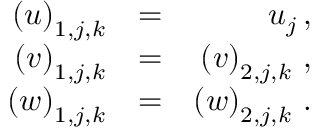Convert formula to latex. <formula><loc_0><loc_0><loc_500><loc_500>\begin{array} { r l r } { { \left ( u \right ) _ { 1 , j , k } } } & { = } & { { u _ { j } \, , } } \\ { { \left ( v \right ) _ { 1 , j , k } } } & { = } & { { \left ( v \right ) _ { 2 , j , k } \, , } } \\ { { \left ( w \right ) _ { 1 , j , k } } } & { = } & { { \left ( w \right ) _ { 2 , j , k } \, . } } \end{array}</formula> 